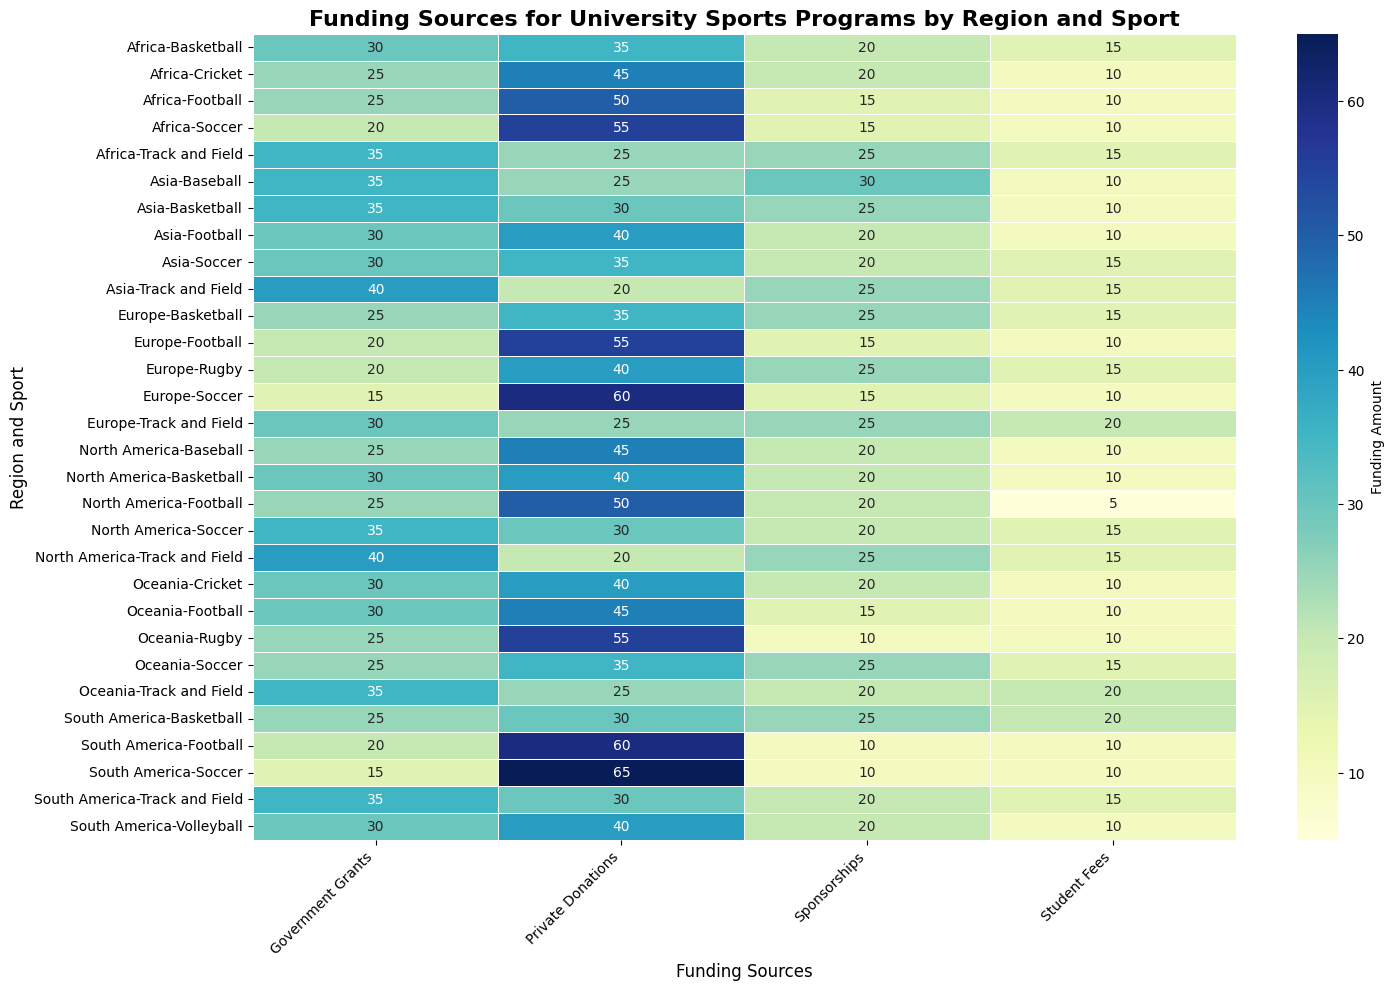Which region has the most private donations for football? To determine which region has the most private donations for football, we look for the regions in the heatmap and compare the private donations value for football. The regions to compare are North America (50), Europe (55), Asia (40), South America (60), Africa (50), and Oceania (45). South America has the highest value.
Answer: South America Which sport in North America has the highest government grants? To identify the sport with the highest government grants in North America, we examine the values for government grants for each sport in North America. The values are Football (25), Basketball (30), Soccer (35), Baseball (25), and Track and Field (40). Track and Field has the highest value.
Answer: Track and Field Compare private donations and sponsorships for basketball in Asia. Which is higher and by how much? In the heatmap for Asia and basketball, the value for private donations is 30 and for sponsorships is 25. To find which is higher and by how much, we subtract the smaller value (sponsorships) from the larger value (private donations): 30 - 25 = 5. Private donations are higher by 5.
Answer: Private donations are higher by 5 What is the average student fee contribution for track and field across all regions? To calculate the average, collect the student fee values for track and field in all regions: North America (15), Europe (20), Asia (15), South America (15), Africa (15), and Oceania (20). The sum is 15 + 20 + 15 + 15 + 15 + 20 = 100. There are 6 regions, so the average is 100 / 6 = 16.67.
Answer: 16.67 Which region and sport pair has the lowest government grants? We need to scan through all region and sport pairs in the heatmap to identify the lowest government grants value. The lowest value noted is 15, which appears for several pairs: Soccer in Europe, Soccer in South America, Soccer in Africa, and Rugby in Europe.
Answer: Soccer in Europe, Soccer in South America, Soccer in Africa, Rugby in Europe What is the sum of private donations and student fees for soccer in Europe? Look at the values for private donations and student fees for soccer in Europe. The values are 60 and 10, respectively. The sum is 60 + 10 = 70.
Answer: 70 Which sports in Europe receive equal funding from government grants and student fees? To find this, compare the values for government grants and student fees for each sport in Europe. For football: 20 and 10; basketball: 25 and 15; soccer: 15 and 10; rugby: 20 and 15; track and field: 30 and 20. None of the sports have equal values for government grants and student fees.
Answer: None Compare the sponsorship funding for cricket in Africa and Oceania and identify which region receives more. The sponsorship value for cricket in Africa is 20, and in Oceania, it is also 20. Both regions receive equal sponsorship funding.
Answer: Equal What is the combined student fee funding for all sports in South America? To find the combined student fee funding for all sports in South America, sum up the student fee values for each sport: Football (10), Basketball (20), Soccer (10), Volleyball (10), and Track and Field (15). The total is 10 + 20 + 10 + 10 + 15 = 65.
Answer: 65 